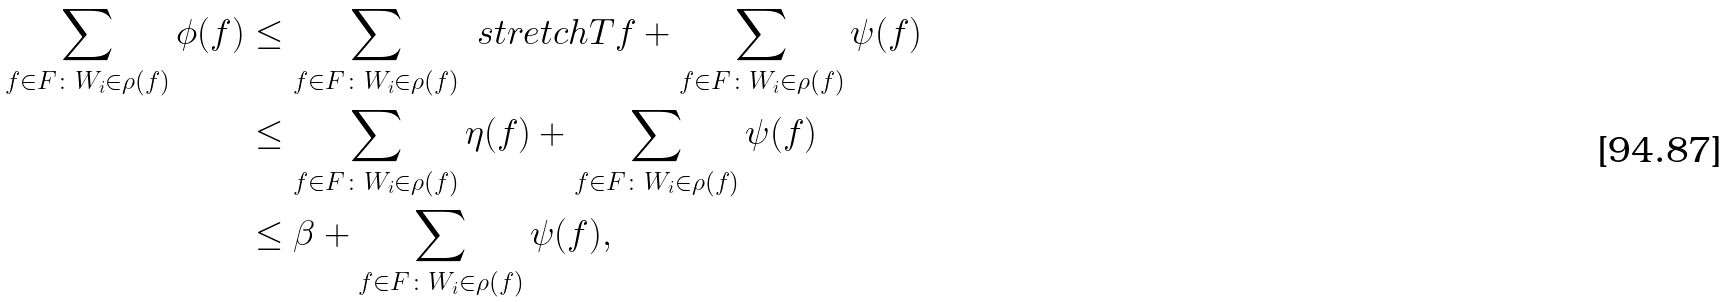<formula> <loc_0><loc_0><loc_500><loc_500>\sum _ { f \in F \colon W _ { i } \in \rho ( f ) } \phi ( f ) & \leq \sum _ { f \in F \colon W _ { i } \in \rho ( f ) } \ s t r e t c h { T } { f } + \sum _ { f \in F \colon W _ { i } \in \rho ( f ) } \psi ( f ) \\ & \leq \sum _ { f \in F \colon W _ { i } \in \rho ( f ) } \eta ( f ) + \sum _ { f \in F \colon W _ { i } \in \rho ( f ) } \psi ( f ) \\ & \leq \beta + \sum _ { f \in F \colon W _ { i } \in \rho ( f ) } \psi ( f ) ,</formula> 